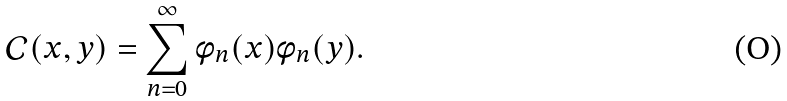Convert formula to latex. <formula><loc_0><loc_0><loc_500><loc_500>\mathcal { C } ( x , y ) = \sum _ { n = 0 } ^ { \infty } \phi _ { n } ( x ) \phi _ { n } ( y ) .</formula> 